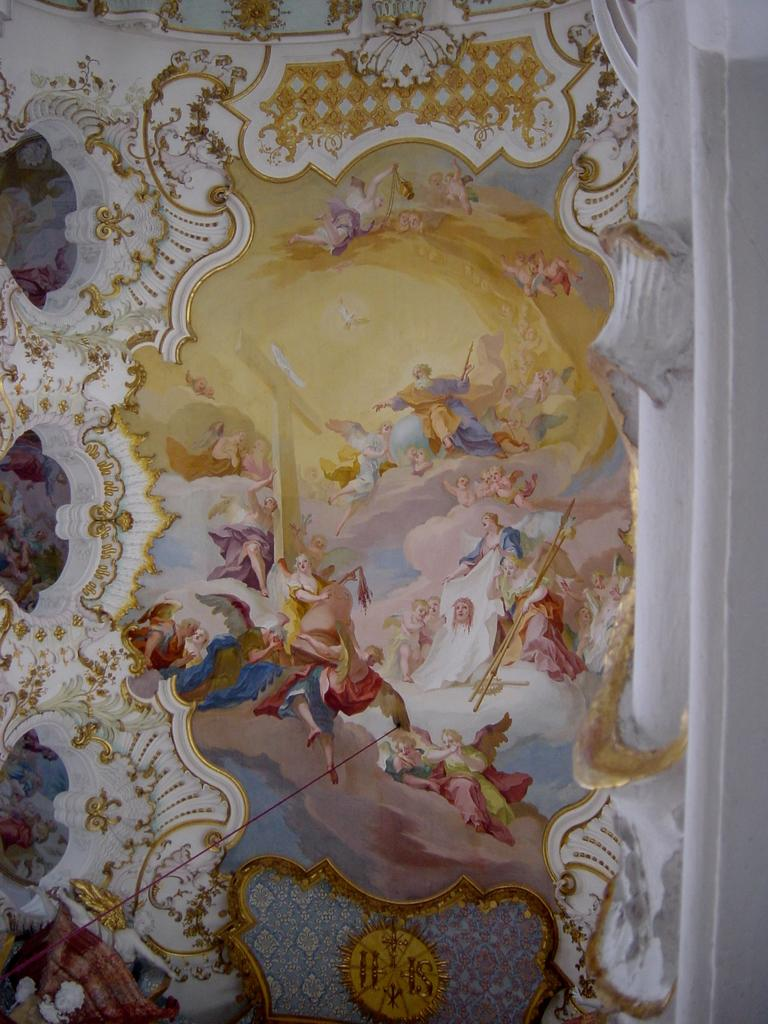What is on the wall in the image? There is a painting on the wall. What type of pencil can be seen being used to draw the painting on the wall? There is no pencil visible in the image, and the painting appears to be complete. 